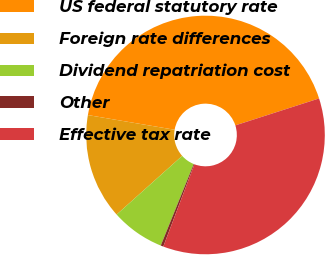Convert chart to OTSL. <chart><loc_0><loc_0><loc_500><loc_500><pie_chart><fcel>US federal statutory rate<fcel>Foreign rate differences<fcel>Dividend repatriation cost<fcel>Other<fcel>Effective tax rate<nl><fcel>42.37%<fcel>14.29%<fcel>7.26%<fcel>0.36%<fcel>35.71%<nl></chart> 